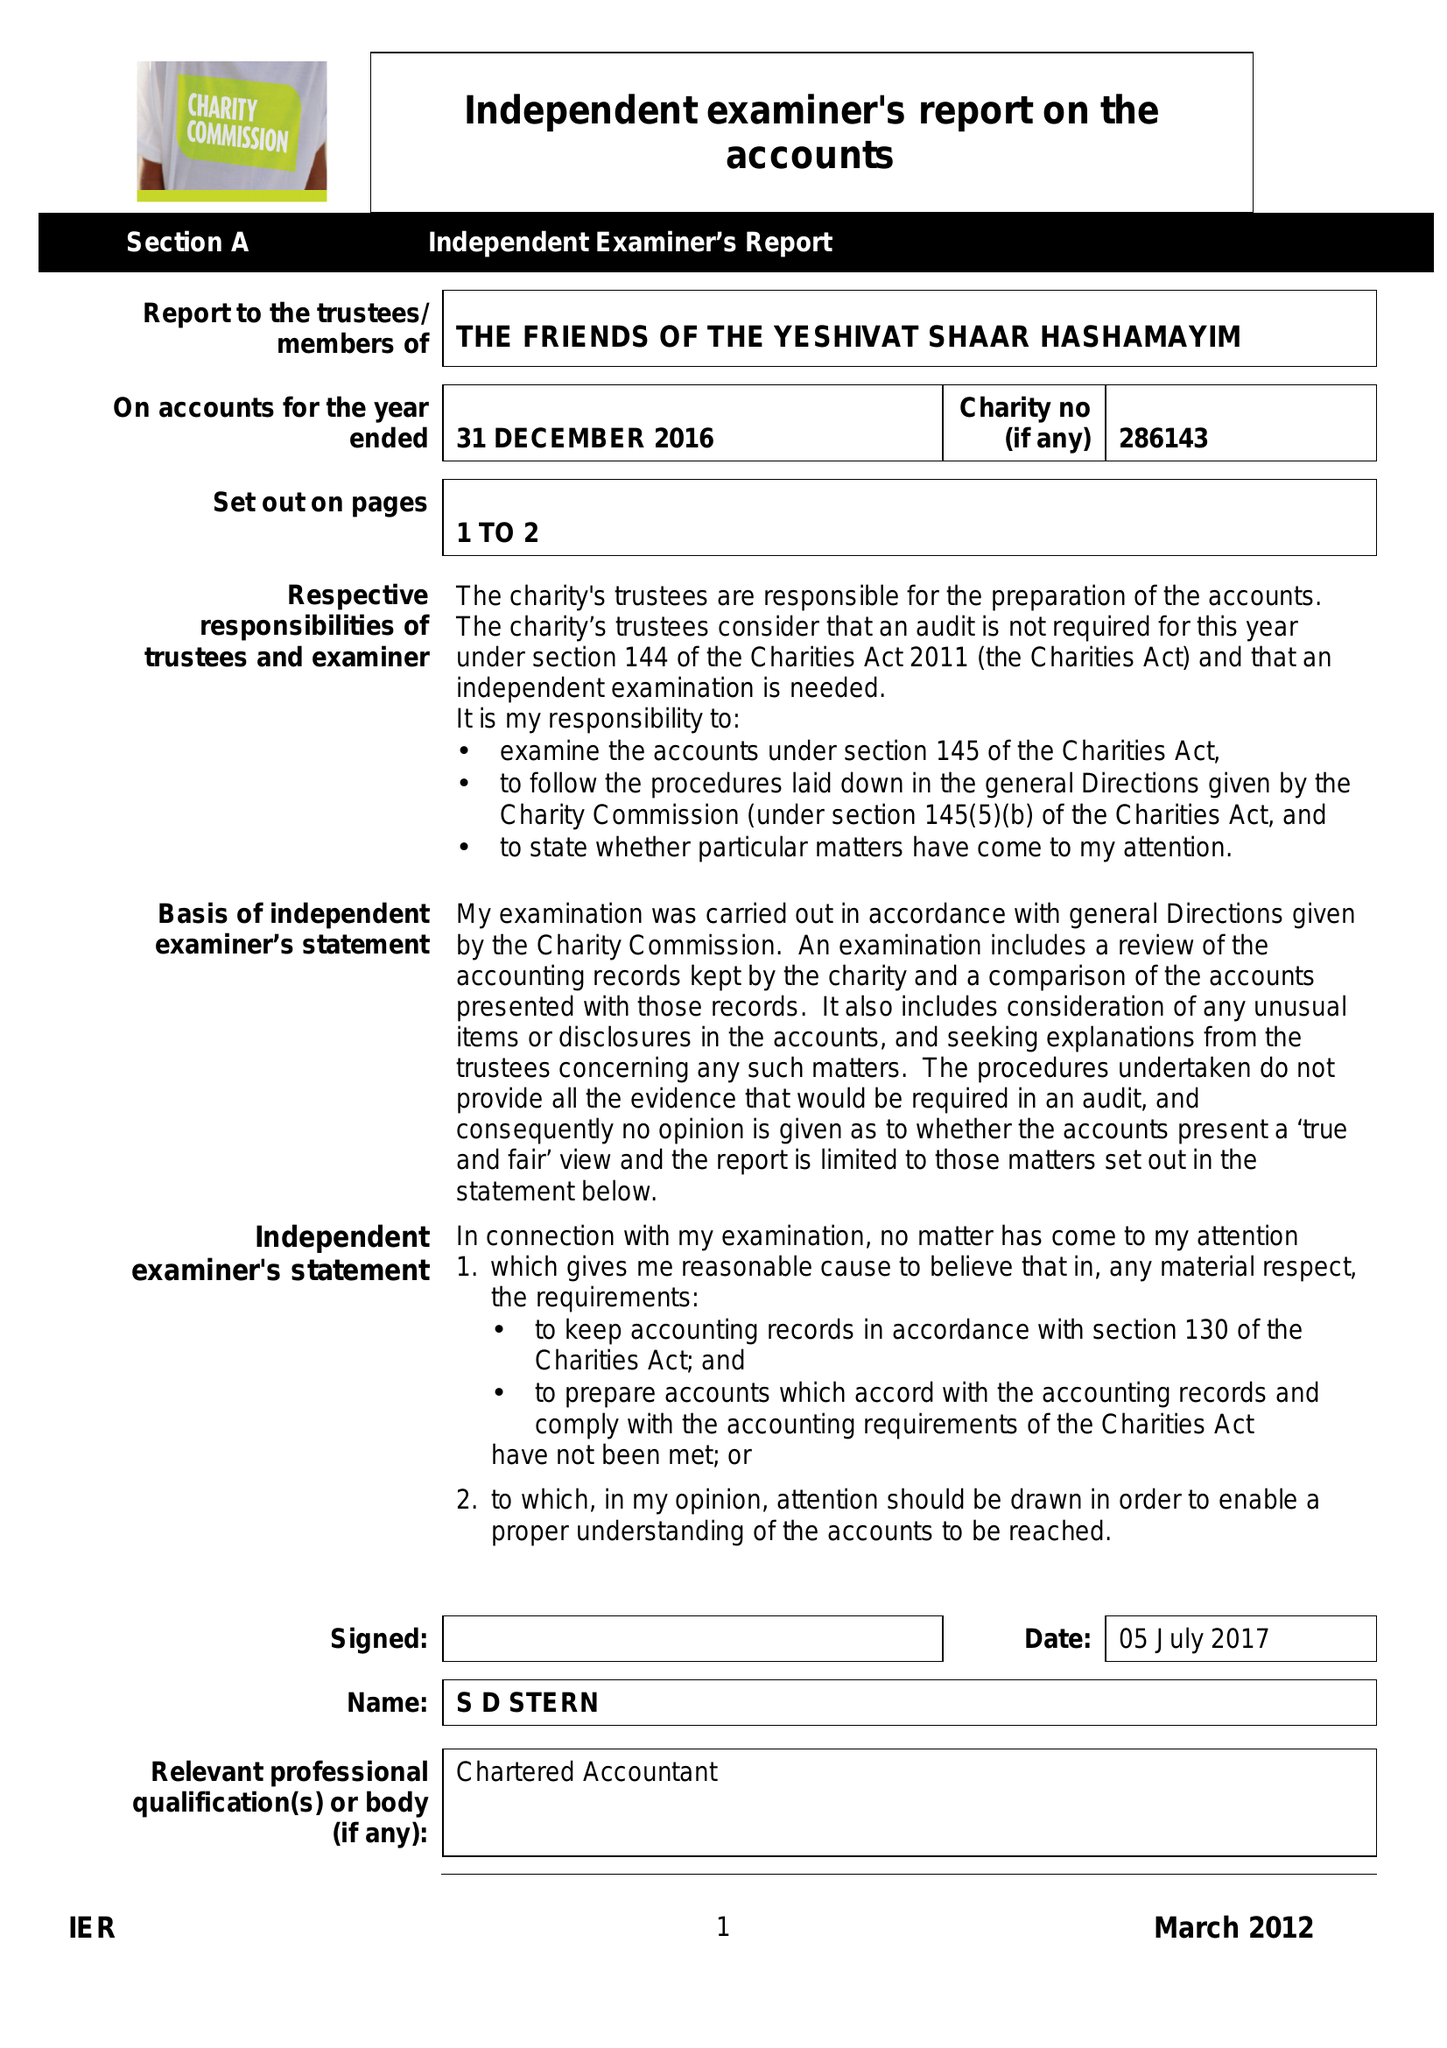What is the value for the address__post_town?
Answer the question using a single word or phrase. LONDON 